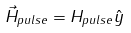Convert formula to latex. <formula><loc_0><loc_0><loc_500><loc_500>\vec { H } _ { p u l s e } = H _ { p u l s e } \hat { y }</formula> 